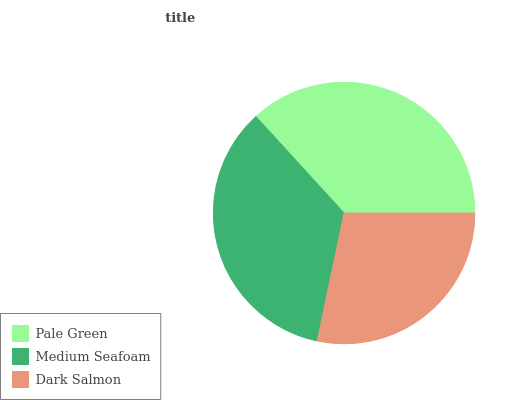Is Dark Salmon the minimum?
Answer yes or no. Yes. Is Pale Green the maximum?
Answer yes or no. Yes. Is Medium Seafoam the minimum?
Answer yes or no. No. Is Medium Seafoam the maximum?
Answer yes or no. No. Is Pale Green greater than Medium Seafoam?
Answer yes or no. Yes. Is Medium Seafoam less than Pale Green?
Answer yes or no. Yes. Is Medium Seafoam greater than Pale Green?
Answer yes or no. No. Is Pale Green less than Medium Seafoam?
Answer yes or no. No. Is Medium Seafoam the high median?
Answer yes or no. Yes. Is Medium Seafoam the low median?
Answer yes or no. Yes. Is Dark Salmon the high median?
Answer yes or no. No. Is Dark Salmon the low median?
Answer yes or no. No. 